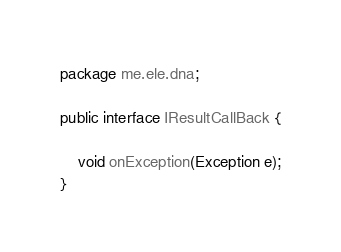<code> <loc_0><loc_0><loc_500><loc_500><_Java_>package me.ele.dna;

public interface IResultCallBack {

    void onException(Exception e);
}
</code> 